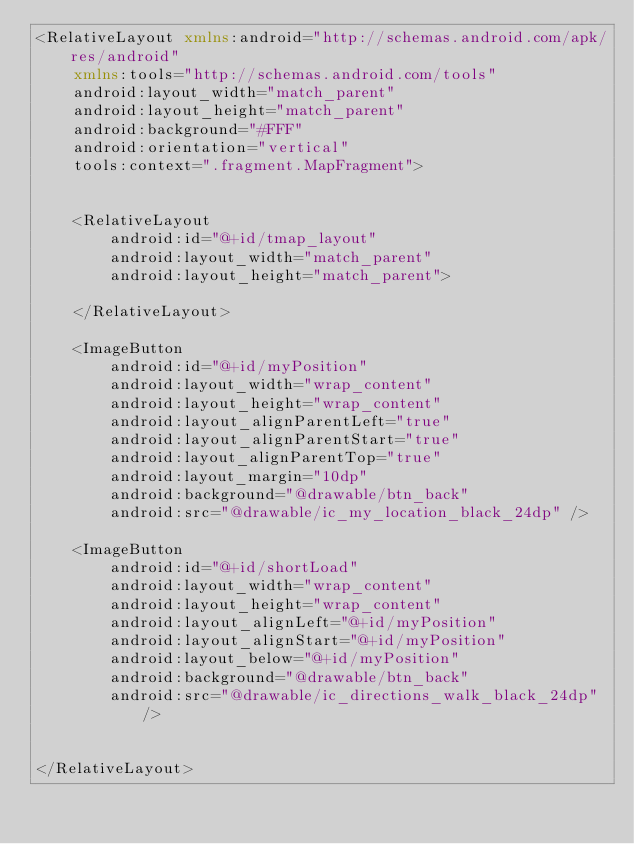<code> <loc_0><loc_0><loc_500><loc_500><_XML_><RelativeLayout xmlns:android="http://schemas.android.com/apk/res/android"
    xmlns:tools="http://schemas.android.com/tools"
    android:layout_width="match_parent"
    android:layout_height="match_parent"
    android:background="#FFF"
    android:orientation="vertical"
    tools:context=".fragment.MapFragment">


    <RelativeLayout
        android:id="@+id/tmap_layout"
        android:layout_width="match_parent"
        android:layout_height="match_parent">

    </RelativeLayout>

    <ImageButton
        android:id="@+id/myPosition"
        android:layout_width="wrap_content"
        android:layout_height="wrap_content"
        android:layout_alignParentLeft="true"
        android:layout_alignParentStart="true"
        android:layout_alignParentTop="true"
        android:layout_margin="10dp"
        android:background="@drawable/btn_back"
        android:src="@drawable/ic_my_location_black_24dp" />

    <ImageButton
        android:id="@+id/shortLoad"
        android:layout_width="wrap_content"
        android:layout_height="wrap_content"
        android:layout_alignLeft="@+id/myPosition"
        android:layout_alignStart="@+id/myPosition"
        android:layout_below="@+id/myPosition"
        android:background="@drawable/btn_back"
        android:src="@drawable/ic_directions_walk_black_24dp" />


</RelativeLayout>

</code> 